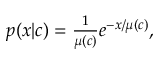<formula> <loc_0><loc_0><loc_500><loc_500>\begin{array} { r } { p ( x | c ) = \frac { 1 } { \mu ( c ) } e ^ { - x / \mu ( c ) } , } \end{array}</formula> 